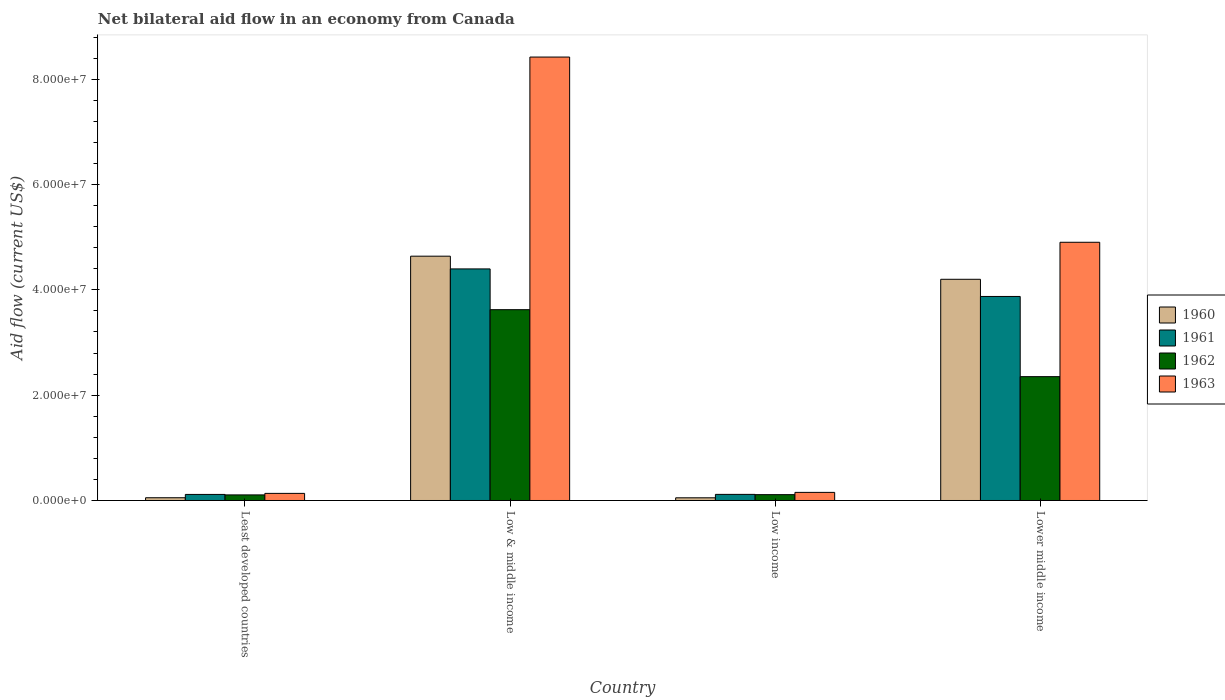How many different coloured bars are there?
Keep it short and to the point. 4. Are the number of bars per tick equal to the number of legend labels?
Make the answer very short. Yes. Are the number of bars on each tick of the X-axis equal?
Make the answer very short. Yes. How many bars are there on the 4th tick from the right?
Your response must be concise. 4. What is the label of the 4th group of bars from the left?
Ensure brevity in your answer.  Lower middle income. In how many cases, is the number of bars for a given country not equal to the number of legend labels?
Your answer should be very brief. 0. What is the net bilateral aid flow in 1960 in Least developed countries?
Give a very brief answer. 5.20e+05. Across all countries, what is the maximum net bilateral aid flow in 1960?
Your answer should be compact. 4.64e+07. Across all countries, what is the minimum net bilateral aid flow in 1963?
Keep it short and to the point. 1.35e+06. In which country was the net bilateral aid flow in 1963 minimum?
Ensure brevity in your answer.  Least developed countries. What is the total net bilateral aid flow in 1961 in the graph?
Your answer should be compact. 8.50e+07. What is the difference between the net bilateral aid flow in 1961 in Low & middle income and that in Low income?
Your response must be concise. 4.28e+07. What is the difference between the net bilateral aid flow in 1962 in Low & middle income and the net bilateral aid flow in 1961 in Low income?
Your answer should be compact. 3.51e+07. What is the average net bilateral aid flow in 1963 per country?
Provide a succinct answer. 3.40e+07. What is the difference between the net bilateral aid flow of/in 1963 and net bilateral aid flow of/in 1961 in Least developed countries?
Offer a terse response. 2.00e+05. What is the ratio of the net bilateral aid flow in 1960 in Low income to that in Lower middle income?
Your answer should be compact. 0.01. Is the net bilateral aid flow in 1963 in Least developed countries less than that in Lower middle income?
Your answer should be compact. Yes. What is the difference between the highest and the second highest net bilateral aid flow in 1962?
Ensure brevity in your answer.  1.27e+07. What is the difference between the highest and the lowest net bilateral aid flow in 1960?
Keep it short and to the point. 4.59e+07. In how many countries, is the net bilateral aid flow in 1963 greater than the average net bilateral aid flow in 1963 taken over all countries?
Your answer should be very brief. 2. Is it the case that in every country, the sum of the net bilateral aid flow in 1961 and net bilateral aid flow in 1960 is greater than the sum of net bilateral aid flow in 1962 and net bilateral aid flow in 1963?
Your response must be concise. No. What does the 1st bar from the left in Low & middle income represents?
Your answer should be very brief. 1960. Are all the bars in the graph horizontal?
Offer a terse response. No. How many countries are there in the graph?
Make the answer very short. 4. Does the graph contain any zero values?
Ensure brevity in your answer.  No. Does the graph contain grids?
Your answer should be compact. No. Where does the legend appear in the graph?
Make the answer very short. Center right. What is the title of the graph?
Offer a terse response. Net bilateral aid flow in an economy from Canada. What is the Aid flow (current US$) in 1960 in Least developed countries?
Your answer should be very brief. 5.20e+05. What is the Aid flow (current US$) in 1961 in Least developed countries?
Provide a succinct answer. 1.15e+06. What is the Aid flow (current US$) of 1962 in Least developed countries?
Keep it short and to the point. 1.06e+06. What is the Aid flow (current US$) in 1963 in Least developed countries?
Ensure brevity in your answer.  1.35e+06. What is the Aid flow (current US$) in 1960 in Low & middle income?
Make the answer very short. 4.64e+07. What is the Aid flow (current US$) of 1961 in Low & middle income?
Your answer should be very brief. 4.40e+07. What is the Aid flow (current US$) of 1962 in Low & middle income?
Your answer should be very brief. 3.62e+07. What is the Aid flow (current US$) in 1963 in Low & middle income?
Offer a terse response. 8.42e+07. What is the Aid flow (current US$) in 1960 in Low income?
Your response must be concise. 5.10e+05. What is the Aid flow (current US$) in 1961 in Low income?
Your answer should be compact. 1.16e+06. What is the Aid flow (current US$) of 1962 in Low income?
Provide a short and direct response. 1.11e+06. What is the Aid flow (current US$) in 1963 in Low income?
Provide a succinct answer. 1.54e+06. What is the Aid flow (current US$) of 1960 in Lower middle income?
Provide a succinct answer. 4.20e+07. What is the Aid flow (current US$) in 1961 in Lower middle income?
Give a very brief answer. 3.88e+07. What is the Aid flow (current US$) of 1962 in Lower middle income?
Give a very brief answer. 2.35e+07. What is the Aid flow (current US$) in 1963 in Lower middle income?
Your response must be concise. 4.90e+07. Across all countries, what is the maximum Aid flow (current US$) of 1960?
Give a very brief answer. 4.64e+07. Across all countries, what is the maximum Aid flow (current US$) of 1961?
Keep it short and to the point. 4.40e+07. Across all countries, what is the maximum Aid flow (current US$) of 1962?
Keep it short and to the point. 3.62e+07. Across all countries, what is the maximum Aid flow (current US$) in 1963?
Make the answer very short. 8.42e+07. Across all countries, what is the minimum Aid flow (current US$) of 1960?
Ensure brevity in your answer.  5.10e+05. Across all countries, what is the minimum Aid flow (current US$) in 1961?
Your response must be concise. 1.15e+06. Across all countries, what is the minimum Aid flow (current US$) of 1962?
Your answer should be compact. 1.06e+06. Across all countries, what is the minimum Aid flow (current US$) in 1963?
Provide a short and direct response. 1.35e+06. What is the total Aid flow (current US$) of 1960 in the graph?
Provide a short and direct response. 8.94e+07. What is the total Aid flow (current US$) in 1961 in the graph?
Provide a succinct answer. 8.50e+07. What is the total Aid flow (current US$) in 1962 in the graph?
Ensure brevity in your answer.  6.19e+07. What is the total Aid flow (current US$) in 1963 in the graph?
Provide a short and direct response. 1.36e+08. What is the difference between the Aid flow (current US$) in 1960 in Least developed countries and that in Low & middle income?
Keep it short and to the point. -4.59e+07. What is the difference between the Aid flow (current US$) in 1961 in Least developed countries and that in Low & middle income?
Your response must be concise. -4.28e+07. What is the difference between the Aid flow (current US$) of 1962 in Least developed countries and that in Low & middle income?
Your response must be concise. -3.52e+07. What is the difference between the Aid flow (current US$) of 1963 in Least developed countries and that in Low & middle income?
Offer a very short reply. -8.29e+07. What is the difference between the Aid flow (current US$) in 1960 in Least developed countries and that in Low income?
Give a very brief answer. 10000. What is the difference between the Aid flow (current US$) of 1961 in Least developed countries and that in Low income?
Your answer should be very brief. -10000. What is the difference between the Aid flow (current US$) of 1963 in Least developed countries and that in Low income?
Keep it short and to the point. -1.90e+05. What is the difference between the Aid flow (current US$) of 1960 in Least developed countries and that in Lower middle income?
Give a very brief answer. -4.15e+07. What is the difference between the Aid flow (current US$) in 1961 in Least developed countries and that in Lower middle income?
Make the answer very short. -3.76e+07. What is the difference between the Aid flow (current US$) in 1962 in Least developed countries and that in Lower middle income?
Ensure brevity in your answer.  -2.25e+07. What is the difference between the Aid flow (current US$) in 1963 in Least developed countries and that in Lower middle income?
Offer a terse response. -4.77e+07. What is the difference between the Aid flow (current US$) in 1960 in Low & middle income and that in Low income?
Provide a short and direct response. 4.59e+07. What is the difference between the Aid flow (current US$) of 1961 in Low & middle income and that in Low income?
Offer a very short reply. 4.28e+07. What is the difference between the Aid flow (current US$) of 1962 in Low & middle income and that in Low income?
Make the answer very short. 3.51e+07. What is the difference between the Aid flow (current US$) in 1963 in Low & middle income and that in Low income?
Ensure brevity in your answer.  8.27e+07. What is the difference between the Aid flow (current US$) of 1960 in Low & middle income and that in Lower middle income?
Provide a short and direct response. 4.39e+06. What is the difference between the Aid flow (current US$) in 1961 in Low & middle income and that in Lower middle income?
Keep it short and to the point. 5.23e+06. What is the difference between the Aid flow (current US$) in 1962 in Low & middle income and that in Lower middle income?
Ensure brevity in your answer.  1.27e+07. What is the difference between the Aid flow (current US$) in 1963 in Low & middle income and that in Lower middle income?
Make the answer very short. 3.52e+07. What is the difference between the Aid flow (current US$) in 1960 in Low income and that in Lower middle income?
Keep it short and to the point. -4.15e+07. What is the difference between the Aid flow (current US$) of 1961 in Low income and that in Lower middle income?
Offer a terse response. -3.76e+07. What is the difference between the Aid flow (current US$) in 1962 in Low income and that in Lower middle income?
Your response must be concise. -2.24e+07. What is the difference between the Aid flow (current US$) of 1963 in Low income and that in Lower middle income?
Ensure brevity in your answer.  -4.75e+07. What is the difference between the Aid flow (current US$) in 1960 in Least developed countries and the Aid flow (current US$) in 1961 in Low & middle income?
Make the answer very short. -4.35e+07. What is the difference between the Aid flow (current US$) in 1960 in Least developed countries and the Aid flow (current US$) in 1962 in Low & middle income?
Offer a very short reply. -3.57e+07. What is the difference between the Aid flow (current US$) in 1960 in Least developed countries and the Aid flow (current US$) in 1963 in Low & middle income?
Provide a succinct answer. -8.37e+07. What is the difference between the Aid flow (current US$) of 1961 in Least developed countries and the Aid flow (current US$) of 1962 in Low & middle income?
Your response must be concise. -3.51e+07. What is the difference between the Aid flow (current US$) of 1961 in Least developed countries and the Aid flow (current US$) of 1963 in Low & middle income?
Your response must be concise. -8.31e+07. What is the difference between the Aid flow (current US$) of 1962 in Least developed countries and the Aid flow (current US$) of 1963 in Low & middle income?
Provide a short and direct response. -8.32e+07. What is the difference between the Aid flow (current US$) in 1960 in Least developed countries and the Aid flow (current US$) in 1961 in Low income?
Ensure brevity in your answer.  -6.40e+05. What is the difference between the Aid flow (current US$) of 1960 in Least developed countries and the Aid flow (current US$) of 1962 in Low income?
Ensure brevity in your answer.  -5.90e+05. What is the difference between the Aid flow (current US$) of 1960 in Least developed countries and the Aid flow (current US$) of 1963 in Low income?
Give a very brief answer. -1.02e+06. What is the difference between the Aid flow (current US$) in 1961 in Least developed countries and the Aid flow (current US$) in 1962 in Low income?
Provide a short and direct response. 4.00e+04. What is the difference between the Aid flow (current US$) in 1961 in Least developed countries and the Aid flow (current US$) in 1963 in Low income?
Provide a short and direct response. -3.90e+05. What is the difference between the Aid flow (current US$) in 1962 in Least developed countries and the Aid flow (current US$) in 1963 in Low income?
Provide a short and direct response. -4.80e+05. What is the difference between the Aid flow (current US$) in 1960 in Least developed countries and the Aid flow (current US$) in 1961 in Lower middle income?
Your response must be concise. -3.82e+07. What is the difference between the Aid flow (current US$) in 1960 in Least developed countries and the Aid flow (current US$) in 1962 in Lower middle income?
Offer a terse response. -2.30e+07. What is the difference between the Aid flow (current US$) in 1960 in Least developed countries and the Aid flow (current US$) in 1963 in Lower middle income?
Provide a short and direct response. -4.85e+07. What is the difference between the Aid flow (current US$) in 1961 in Least developed countries and the Aid flow (current US$) in 1962 in Lower middle income?
Your response must be concise. -2.24e+07. What is the difference between the Aid flow (current US$) in 1961 in Least developed countries and the Aid flow (current US$) in 1963 in Lower middle income?
Offer a very short reply. -4.79e+07. What is the difference between the Aid flow (current US$) in 1962 in Least developed countries and the Aid flow (current US$) in 1963 in Lower middle income?
Provide a succinct answer. -4.80e+07. What is the difference between the Aid flow (current US$) in 1960 in Low & middle income and the Aid flow (current US$) in 1961 in Low income?
Ensure brevity in your answer.  4.52e+07. What is the difference between the Aid flow (current US$) of 1960 in Low & middle income and the Aid flow (current US$) of 1962 in Low income?
Your answer should be compact. 4.53e+07. What is the difference between the Aid flow (current US$) of 1960 in Low & middle income and the Aid flow (current US$) of 1963 in Low income?
Your answer should be compact. 4.49e+07. What is the difference between the Aid flow (current US$) in 1961 in Low & middle income and the Aid flow (current US$) in 1962 in Low income?
Ensure brevity in your answer.  4.29e+07. What is the difference between the Aid flow (current US$) of 1961 in Low & middle income and the Aid flow (current US$) of 1963 in Low income?
Offer a terse response. 4.24e+07. What is the difference between the Aid flow (current US$) of 1962 in Low & middle income and the Aid flow (current US$) of 1963 in Low income?
Your answer should be very brief. 3.47e+07. What is the difference between the Aid flow (current US$) of 1960 in Low & middle income and the Aid flow (current US$) of 1961 in Lower middle income?
Your response must be concise. 7.65e+06. What is the difference between the Aid flow (current US$) in 1960 in Low & middle income and the Aid flow (current US$) in 1962 in Lower middle income?
Offer a very short reply. 2.29e+07. What is the difference between the Aid flow (current US$) of 1960 in Low & middle income and the Aid flow (current US$) of 1963 in Lower middle income?
Ensure brevity in your answer.  -2.64e+06. What is the difference between the Aid flow (current US$) in 1961 in Low & middle income and the Aid flow (current US$) in 1962 in Lower middle income?
Give a very brief answer. 2.05e+07. What is the difference between the Aid flow (current US$) in 1961 in Low & middle income and the Aid flow (current US$) in 1963 in Lower middle income?
Provide a short and direct response. -5.06e+06. What is the difference between the Aid flow (current US$) of 1962 in Low & middle income and the Aid flow (current US$) of 1963 in Lower middle income?
Offer a very short reply. -1.28e+07. What is the difference between the Aid flow (current US$) in 1960 in Low income and the Aid flow (current US$) in 1961 in Lower middle income?
Your answer should be very brief. -3.82e+07. What is the difference between the Aid flow (current US$) in 1960 in Low income and the Aid flow (current US$) in 1962 in Lower middle income?
Offer a very short reply. -2.30e+07. What is the difference between the Aid flow (current US$) in 1960 in Low income and the Aid flow (current US$) in 1963 in Lower middle income?
Your answer should be compact. -4.85e+07. What is the difference between the Aid flow (current US$) in 1961 in Low income and the Aid flow (current US$) in 1962 in Lower middle income?
Give a very brief answer. -2.24e+07. What is the difference between the Aid flow (current US$) in 1961 in Low income and the Aid flow (current US$) in 1963 in Lower middle income?
Your response must be concise. -4.79e+07. What is the difference between the Aid flow (current US$) in 1962 in Low income and the Aid flow (current US$) in 1963 in Lower middle income?
Provide a succinct answer. -4.79e+07. What is the average Aid flow (current US$) in 1960 per country?
Offer a terse response. 2.24e+07. What is the average Aid flow (current US$) in 1961 per country?
Your answer should be very brief. 2.13e+07. What is the average Aid flow (current US$) of 1962 per country?
Ensure brevity in your answer.  1.55e+07. What is the average Aid flow (current US$) of 1963 per country?
Offer a terse response. 3.40e+07. What is the difference between the Aid flow (current US$) in 1960 and Aid flow (current US$) in 1961 in Least developed countries?
Make the answer very short. -6.30e+05. What is the difference between the Aid flow (current US$) of 1960 and Aid flow (current US$) of 1962 in Least developed countries?
Your answer should be very brief. -5.40e+05. What is the difference between the Aid flow (current US$) in 1960 and Aid flow (current US$) in 1963 in Least developed countries?
Your answer should be very brief. -8.30e+05. What is the difference between the Aid flow (current US$) of 1960 and Aid flow (current US$) of 1961 in Low & middle income?
Your answer should be very brief. 2.42e+06. What is the difference between the Aid flow (current US$) of 1960 and Aid flow (current US$) of 1962 in Low & middle income?
Your response must be concise. 1.02e+07. What is the difference between the Aid flow (current US$) of 1960 and Aid flow (current US$) of 1963 in Low & middle income?
Your answer should be compact. -3.78e+07. What is the difference between the Aid flow (current US$) in 1961 and Aid flow (current US$) in 1962 in Low & middle income?
Give a very brief answer. 7.74e+06. What is the difference between the Aid flow (current US$) in 1961 and Aid flow (current US$) in 1963 in Low & middle income?
Offer a terse response. -4.02e+07. What is the difference between the Aid flow (current US$) of 1962 and Aid flow (current US$) of 1963 in Low & middle income?
Make the answer very short. -4.80e+07. What is the difference between the Aid flow (current US$) in 1960 and Aid flow (current US$) in 1961 in Low income?
Your answer should be very brief. -6.50e+05. What is the difference between the Aid flow (current US$) in 1960 and Aid flow (current US$) in 1962 in Low income?
Offer a terse response. -6.00e+05. What is the difference between the Aid flow (current US$) in 1960 and Aid flow (current US$) in 1963 in Low income?
Provide a succinct answer. -1.03e+06. What is the difference between the Aid flow (current US$) of 1961 and Aid flow (current US$) of 1963 in Low income?
Provide a short and direct response. -3.80e+05. What is the difference between the Aid flow (current US$) in 1962 and Aid flow (current US$) in 1963 in Low income?
Provide a short and direct response. -4.30e+05. What is the difference between the Aid flow (current US$) in 1960 and Aid flow (current US$) in 1961 in Lower middle income?
Your answer should be compact. 3.26e+06. What is the difference between the Aid flow (current US$) of 1960 and Aid flow (current US$) of 1962 in Lower middle income?
Your answer should be compact. 1.85e+07. What is the difference between the Aid flow (current US$) of 1960 and Aid flow (current US$) of 1963 in Lower middle income?
Give a very brief answer. -7.03e+06. What is the difference between the Aid flow (current US$) of 1961 and Aid flow (current US$) of 1962 in Lower middle income?
Your answer should be compact. 1.52e+07. What is the difference between the Aid flow (current US$) in 1961 and Aid flow (current US$) in 1963 in Lower middle income?
Provide a succinct answer. -1.03e+07. What is the difference between the Aid flow (current US$) in 1962 and Aid flow (current US$) in 1963 in Lower middle income?
Offer a very short reply. -2.55e+07. What is the ratio of the Aid flow (current US$) of 1960 in Least developed countries to that in Low & middle income?
Offer a terse response. 0.01. What is the ratio of the Aid flow (current US$) of 1961 in Least developed countries to that in Low & middle income?
Offer a terse response. 0.03. What is the ratio of the Aid flow (current US$) in 1962 in Least developed countries to that in Low & middle income?
Offer a very short reply. 0.03. What is the ratio of the Aid flow (current US$) of 1963 in Least developed countries to that in Low & middle income?
Give a very brief answer. 0.02. What is the ratio of the Aid flow (current US$) of 1960 in Least developed countries to that in Low income?
Provide a short and direct response. 1.02. What is the ratio of the Aid flow (current US$) of 1962 in Least developed countries to that in Low income?
Provide a succinct answer. 0.95. What is the ratio of the Aid flow (current US$) of 1963 in Least developed countries to that in Low income?
Ensure brevity in your answer.  0.88. What is the ratio of the Aid flow (current US$) in 1960 in Least developed countries to that in Lower middle income?
Your answer should be very brief. 0.01. What is the ratio of the Aid flow (current US$) of 1961 in Least developed countries to that in Lower middle income?
Your response must be concise. 0.03. What is the ratio of the Aid flow (current US$) in 1962 in Least developed countries to that in Lower middle income?
Your answer should be very brief. 0.05. What is the ratio of the Aid flow (current US$) in 1963 in Least developed countries to that in Lower middle income?
Provide a succinct answer. 0.03. What is the ratio of the Aid flow (current US$) in 1960 in Low & middle income to that in Low income?
Ensure brevity in your answer.  90.98. What is the ratio of the Aid flow (current US$) of 1961 in Low & middle income to that in Low income?
Give a very brief answer. 37.91. What is the ratio of the Aid flow (current US$) in 1962 in Low & middle income to that in Low income?
Your response must be concise. 32.65. What is the ratio of the Aid flow (current US$) in 1963 in Low & middle income to that in Low income?
Keep it short and to the point. 54.69. What is the ratio of the Aid flow (current US$) in 1960 in Low & middle income to that in Lower middle income?
Keep it short and to the point. 1.1. What is the ratio of the Aid flow (current US$) of 1961 in Low & middle income to that in Lower middle income?
Offer a terse response. 1.14. What is the ratio of the Aid flow (current US$) of 1962 in Low & middle income to that in Lower middle income?
Provide a succinct answer. 1.54. What is the ratio of the Aid flow (current US$) in 1963 in Low & middle income to that in Lower middle income?
Offer a very short reply. 1.72. What is the ratio of the Aid flow (current US$) of 1960 in Low income to that in Lower middle income?
Provide a short and direct response. 0.01. What is the ratio of the Aid flow (current US$) in 1961 in Low income to that in Lower middle income?
Make the answer very short. 0.03. What is the ratio of the Aid flow (current US$) in 1962 in Low income to that in Lower middle income?
Ensure brevity in your answer.  0.05. What is the ratio of the Aid flow (current US$) in 1963 in Low income to that in Lower middle income?
Keep it short and to the point. 0.03. What is the difference between the highest and the second highest Aid flow (current US$) of 1960?
Ensure brevity in your answer.  4.39e+06. What is the difference between the highest and the second highest Aid flow (current US$) of 1961?
Keep it short and to the point. 5.23e+06. What is the difference between the highest and the second highest Aid flow (current US$) of 1962?
Keep it short and to the point. 1.27e+07. What is the difference between the highest and the second highest Aid flow (current US$) in 1963?
Give a very brief answer. 3.52e+07. What is the difference between the highest and the lowest Aid flow (current US$) of 1960?
Keep it short and to the point. 4.59e+07. What is the difference between the highest and the lowest Aid flow (current US$) of 1961?
Ensure brevity in your answer.  4.28e+07. What is the difference between the highest and the lowest Aid flow (current US$) in 1962?
Make the answer very short. 3.52e+07. What is the difference between the highest and the lowest Aid flow (current US$) in 1963?
Your response must be concise. 8.29e+07. 